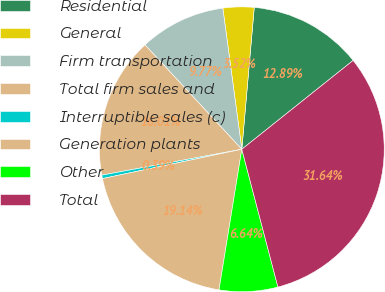Convert chart to OTSL. <chart><loc_0><loc_0><loc_500><loc_500><pie_chart><fcel>Residential<fcel>General<fcel>Firm transportation<fcel>Total firm sales and<fcel>Interruptible sales (c)<fcel>Generation plants<fcel>Other<fcel>Total<nl><fcel>12.89%<fcel>3.52%<fcel>9.77%<fcel>16.01%<fcel>0.39%<fcel>19.14%<fcel>6.64%<fcel>31.64%<nl></chart> 